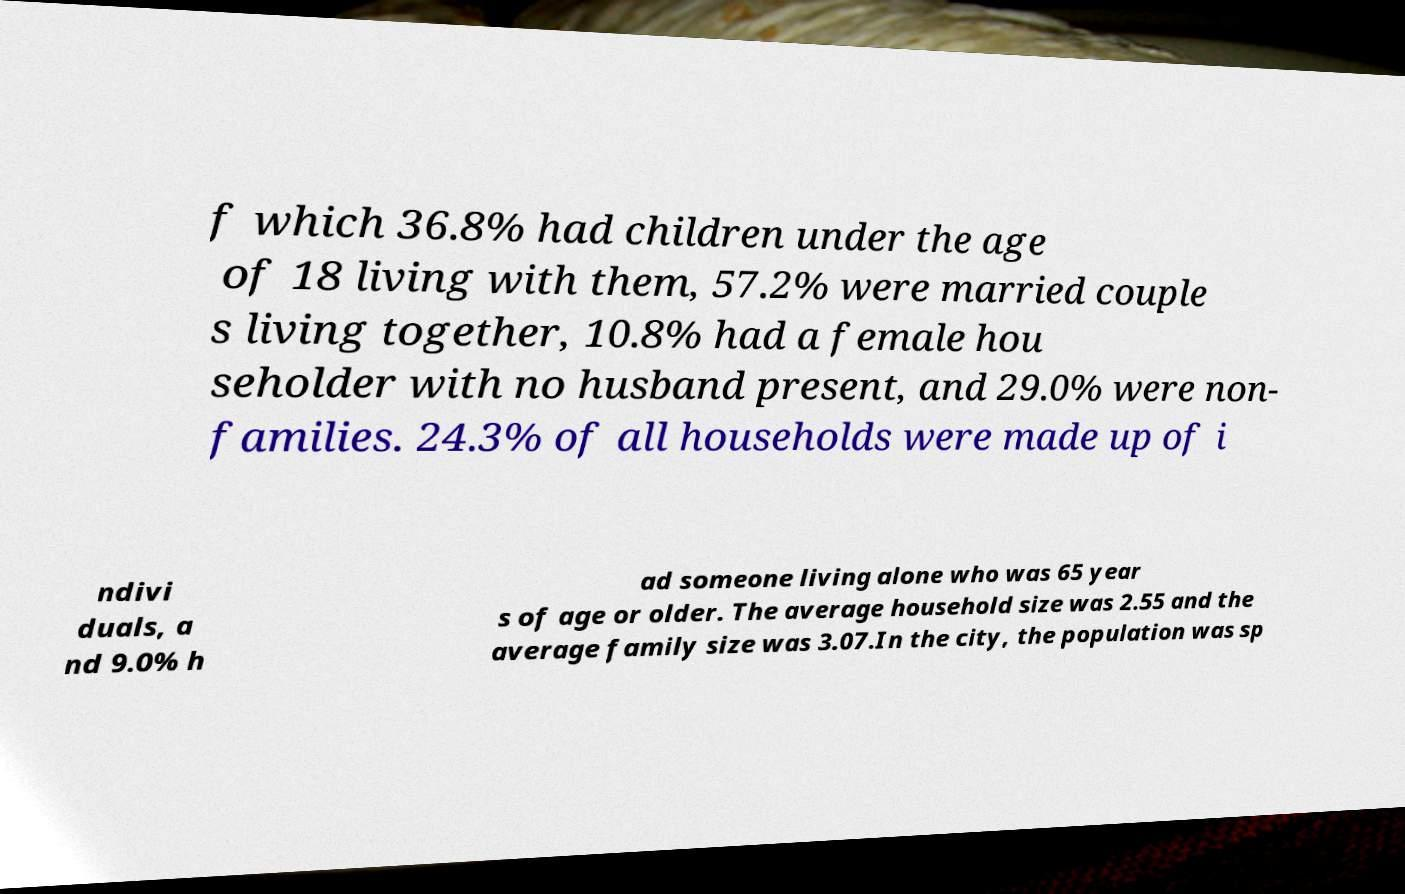Could you extract and type out the text from this image? f which 36.8% had children under the age of 18 living with them, 57.2% were married couple s living together, 10.8% had a female hou seholder with no husband present, and 29.0% were non- families. 24.3% of all households were made up of i ndivi duals, a nd 9.0% h ad someone living alone who was 65 year s of age or older. The average household size was 2.55 and the average family size was 3.07.In the city, the population was sp 